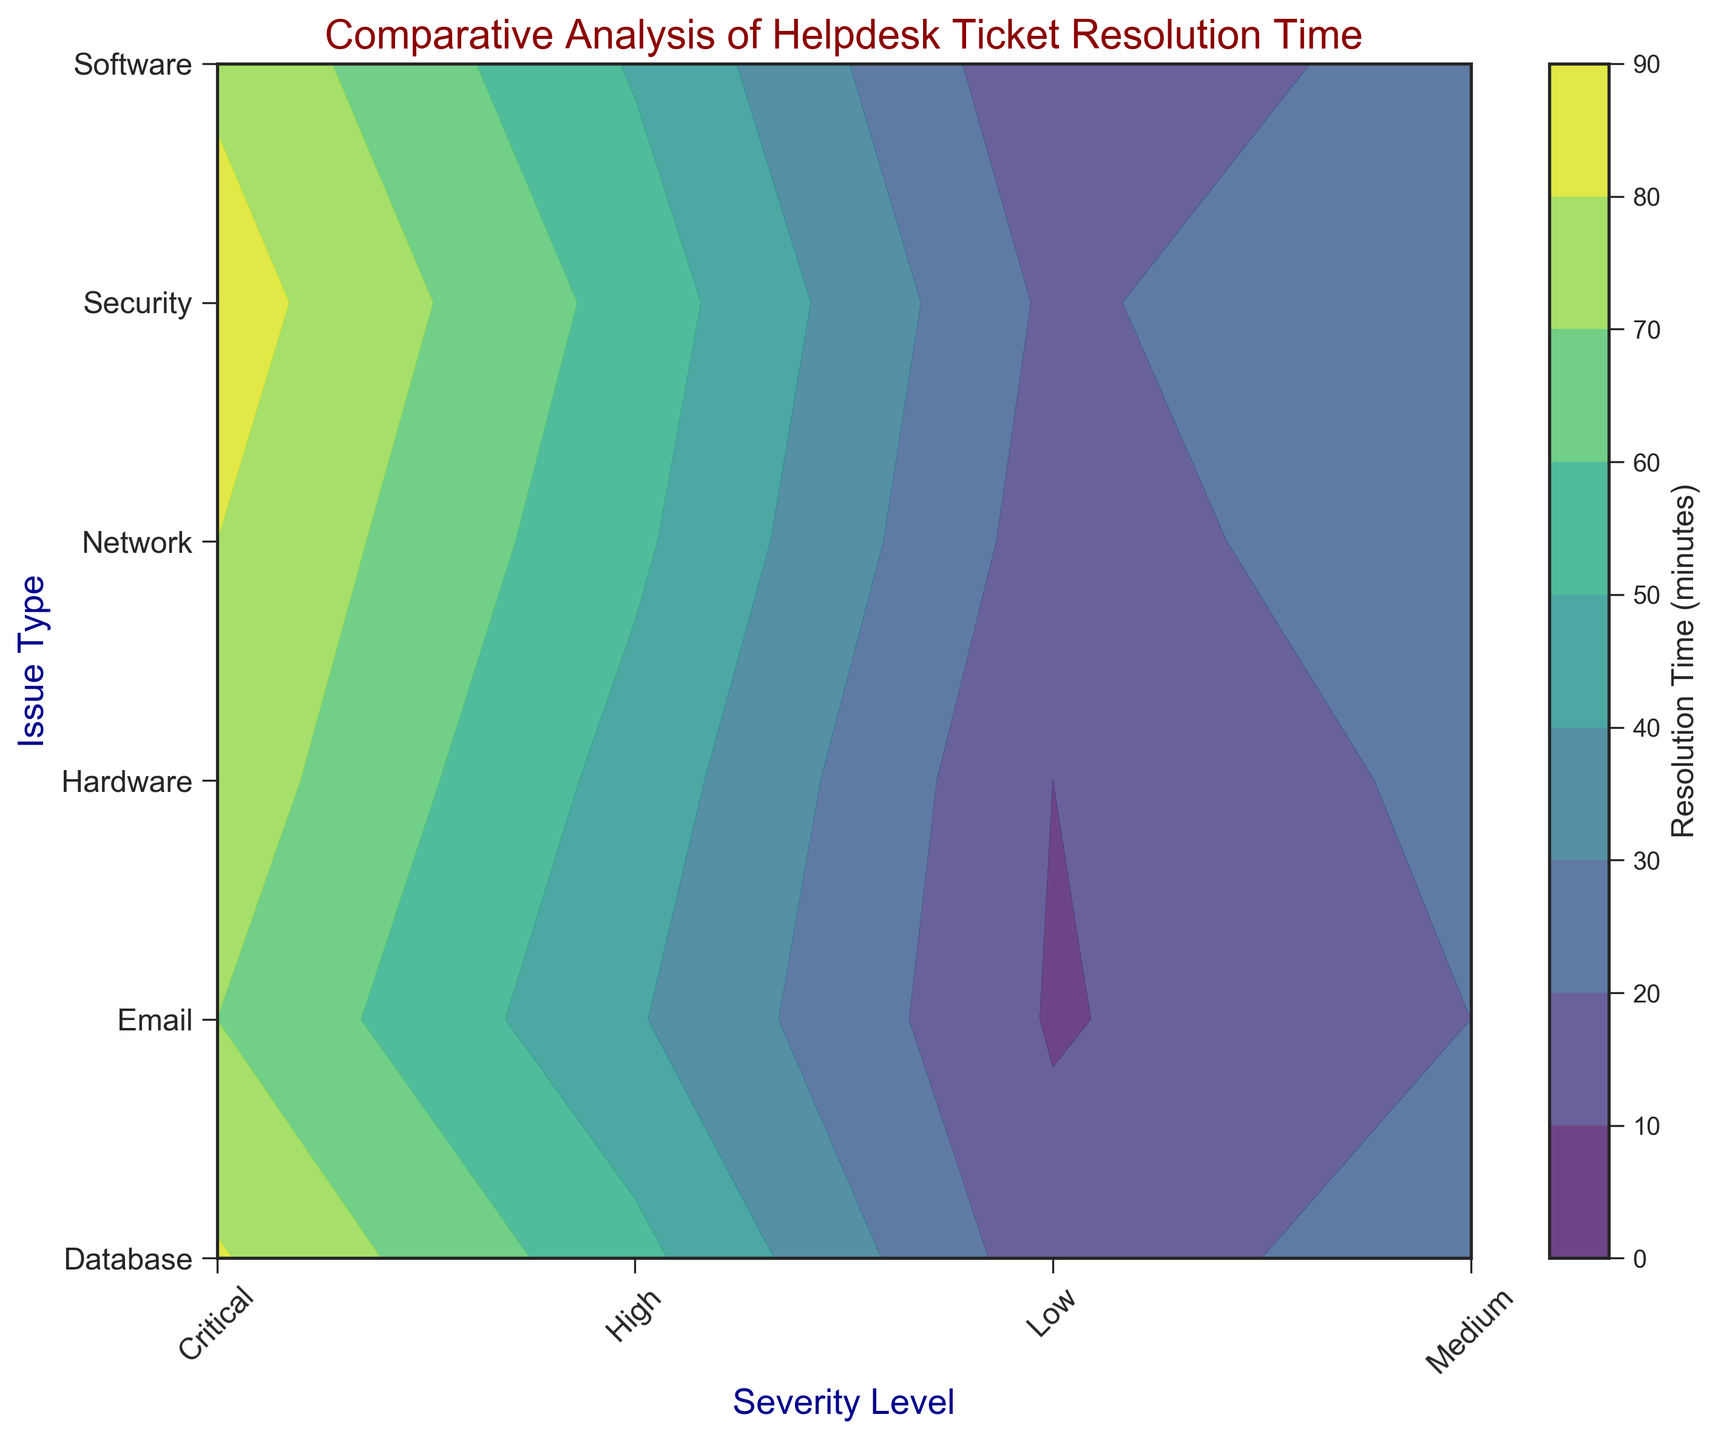What is the average resolution time for Critical severity issues across all issue types? Find the resolution times for Critical severity issues: 80 (Network), 76 (Hardware), 78 (Software), 85 (Security), 70 (Email), 81 (Database). Sum these values to get 470. There are 6 issue types, so divide by 6: \(470 / 6 \approx 78.33\)
Answer: 78.33 Which issue type has the longest resolution time at High severity? Look at the resolution times for High severity issues: 52 (Network), 46 (Hardware), 49 (Software), 56 (Security), 41 (Email), 53 (Database). The longest time is 56 for Security.
Answer: Security How does the resolution time for Medium severity Database issues compare with Medium severity Hardware issues? Find the resolution times for Medium severity: Hardware = 23, Database = 26. Compare the two values: Database (26) is greater than Hardware (23).
Answer: Database is greater Which severity level has the biggest difference in resolution time for Network issues? Look at the Network issue resolution times: Low = 15, Medium = 27, High = 52, Critical = 80. Calculate the differences: Medium - Low = 12, High - Medium = 25, Critical - High = 28. The biggest difference is between High and Critical (28).
Answer: High to Critical What is the median resolution time for Low severity issues across all types? Find Low severity resolution times: Network (15), Hardware (10), Software (12), Security (18), Email (9), Database (14). Order them: 9, 10, 12, 14, 15, 18. Median value is the average of 12 and 14: \( (12+14) / 2 = 13 \)
Answer: 13 Which issue type shows the fastest resolution time for Medium severity? Look at Medium severity times: Network (27), Hardware (23), Software (25), Security (30), Email (20), Database (26). The fastest time is for Email (20).
Answer: Email Compare resolution times between Low and Critical severity for Software issues. Find Software issue resolution times: Low (12), Critical (78). Compare the two values: Critical (78) is greater than Low (12). The difference is 66.
Answer: Critical is greater by 66 What is the color of the region representing resolution times between 20 and 30 minutes? In the contour plot, regions between 20 and 30 minutes are shown in a yellow-green color.
Answer: yellow-green 